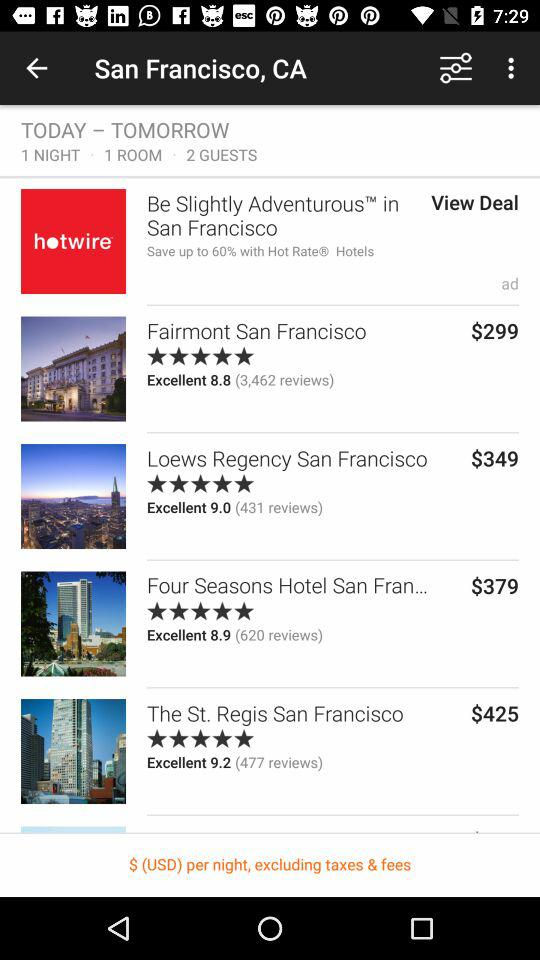What is the given location? The given location is San Francisco, CA. 